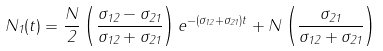<formula> <loc_0><loc_0><loc_500><loc_500>N _ { 1 } ( t ) = \frac { N } { 2 } \left ( \frac { \sigma _ { 1 2 } - \sigma _ { 2 1 } } { \sigma _ { 1 2 } + \sigma _ { 2 1 } } \right ) e ^ { - ( \sigma _ { 1 2 } + \sigma _ { 2 1 } ) t } + N \left ( \frac { \sigma _ { 2 1 } } { \sigma _ { 1 2 } + \sigma _ { 2 1 } } \right )</formula> 